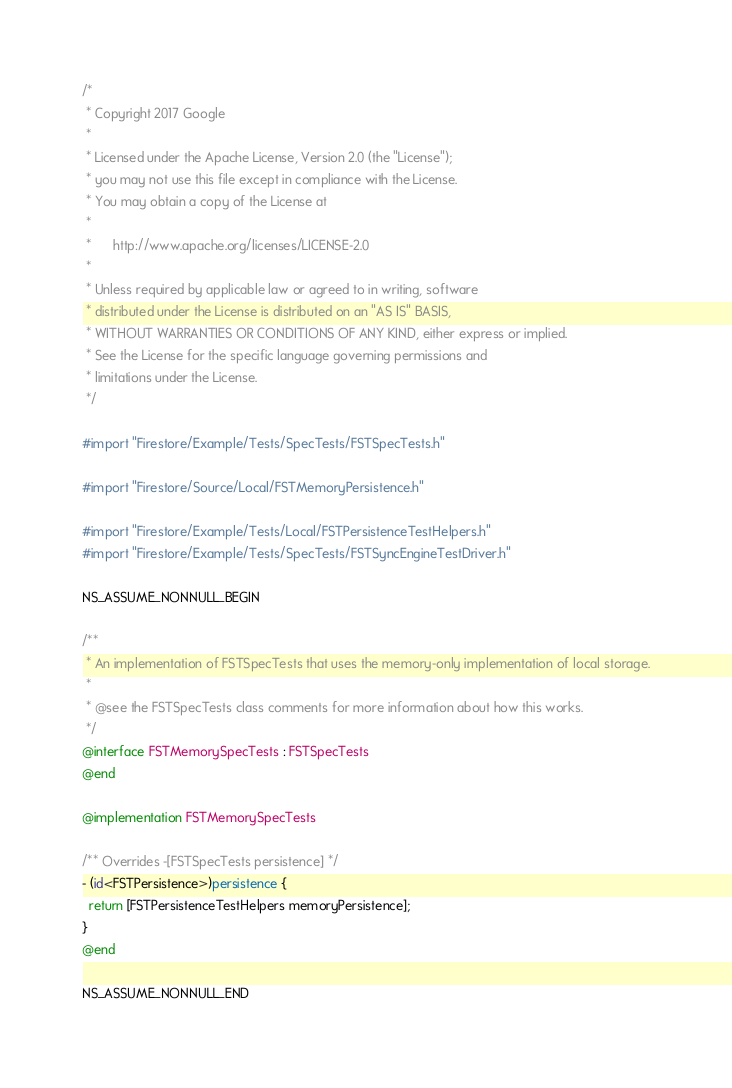Convert code to text. <code><loc_0><loc_0><loc_500><loc_500><_ObjectiveC_>/*
 * Copyright 2017 Google
 *
 * Licensed under the Apache License, Version 2.0 (the "License");
 * you may not use this file except in compliance with the License.
 * You may obtain a copy of the License at
 *
 *      http://www.apache.org/licenses/LICENSE-2.0
 *
 * Unless required by applicable law or agreed to in writing, software
 * distributed under the License is distributed on an "AS IS" BASIS,
 * WITHOUT WARRANTIES OR CONDITIONS OF ANY KIND, either express or implied.
 * See the License for the specific language governing permissions and
 * limitations under the License.
 */

#import "Firestore/Example/Tests/SpecTests/FSTSpecTests.h"

#import "Firestore/Source/Local/FSTMemoryPersistence.h"

#import "Firestore/Example/Tests/Local/FSTPersistenceTestHelpers.h"
#import "Firestore/Example/Tests/SpecTests/FSTSyncEngineTestDriver.h"

NS_ASSUME_NONNULL_BEGIN

/**
 * An implementation of FSTSpecTests that uses the memory-only implementation of local storage.
 *
 * @see the FSTSpecTests class comments for more information about how this works.
 */
@interface FSTMemorySpecTests : FSTSpecTests
@end

@implementation FSTMemorySpecTests

/** Overrides -[FSTSpecTests persistence] */
- (id<FSTPersistence>)persistence {
  return [FSTPersistenceTestHelpers memoryPersistence];
}
@end

NS_ASSUME_NONNULL_END
</code> 